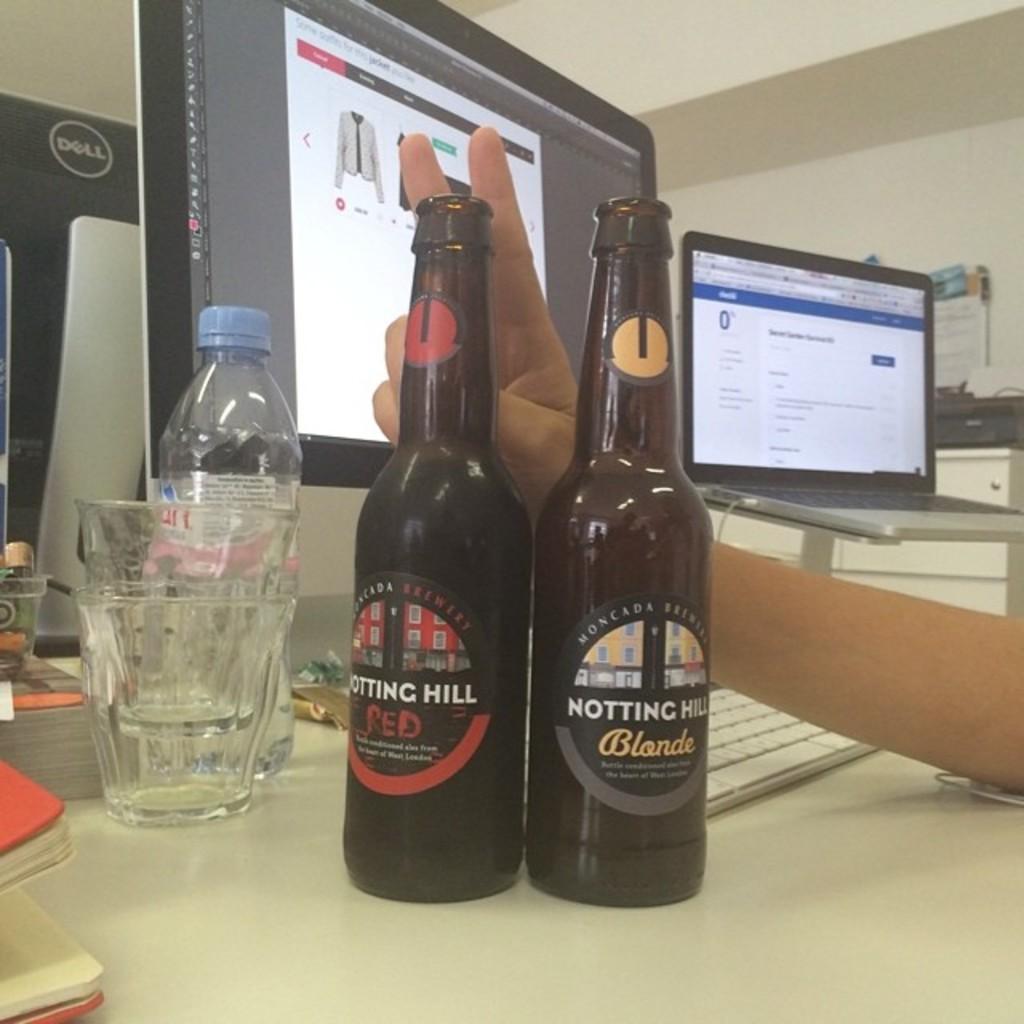What is the brand of beer?
Your response must be concise. Notting hill. What type of beer is in the bottle with the yellow dot on the neck?
Provide a succinct answer. Blonde. 